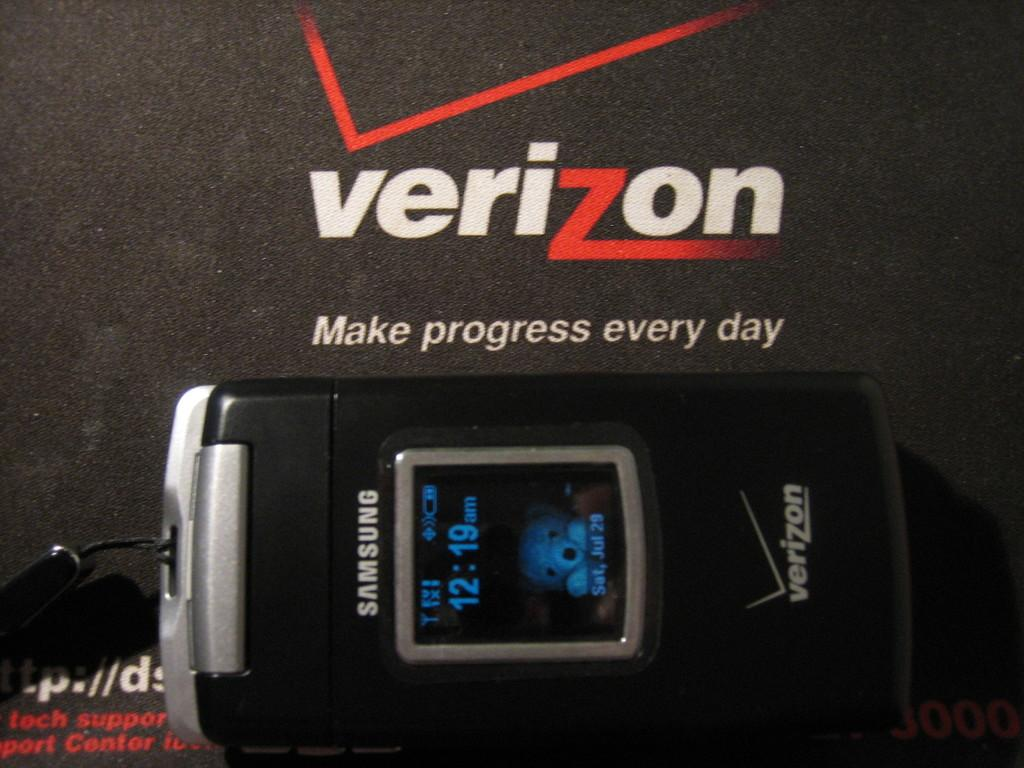<image>
Render a clear and concise summary of the photo. A Samsung flip phone displays a time of 12:19. 